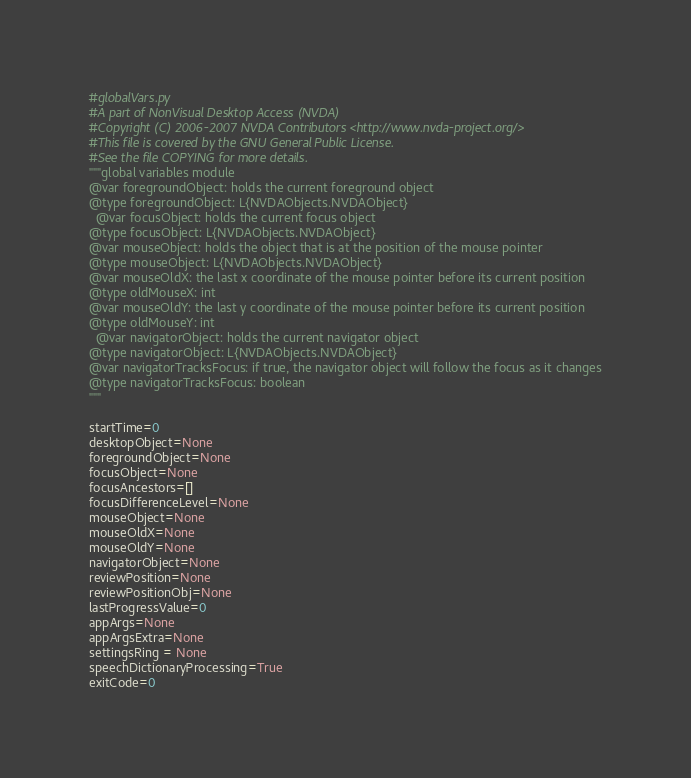<code> <loc_0><loc_0><loc_500><loc_500><_Python_>#globalVars.py
#A part of NonVisual Desktop Access (NVDA)
#Copyright (C) 2006-2007 NVDA Contributors <http://www.nvda-project.org/>
#This file is covered by the GNU General Public License.
#See the file COPYING for more details.
"""global variables module
@var foregroundObject: holds the current foreground object
@type foregroundObject: L{NVDAObjects.NVDAObject}
  @var focusObject: holds the current focus object
@type focusObject: L{NVDAObjects.NVDAObject}
@var mouseObject: holds the object that is at the position of the mouse pointer
@type mouseObject: L{NVDAObjects.NVDAObject}
@var mouseOldX: the last x coordinate of the mouse pointer before its current position
@type oldMouseX: int
@var mouseOldY: the last y coordinate of the mouse pointer before its current position
@type oldMouseY: int
  @var navigatorObject: holds the current navigator object
@type navigatorObject: L{NVDAObjects.NVDAObject}
@var navigatorTracksFocus: if true, the navigator object will follow the focus as it changes
@type navigatorTracksFocus: boolean
"""
 
startTime=0
desktopObject=None
foregroundObject=None
focusObject=None
focusAncestors=[]
focusDifferenceLevel=None
mouseObject=None
mouseOldX=None
mouseOldY=None
navigatorObject=None
reviewPosition=None
reviewPositionObj=None
lastProgressValue=0
appArgs=None
appArgsExtra=None
settingsRing = None
speechDictionaryProcessing=True
exitCode=0
</code> 